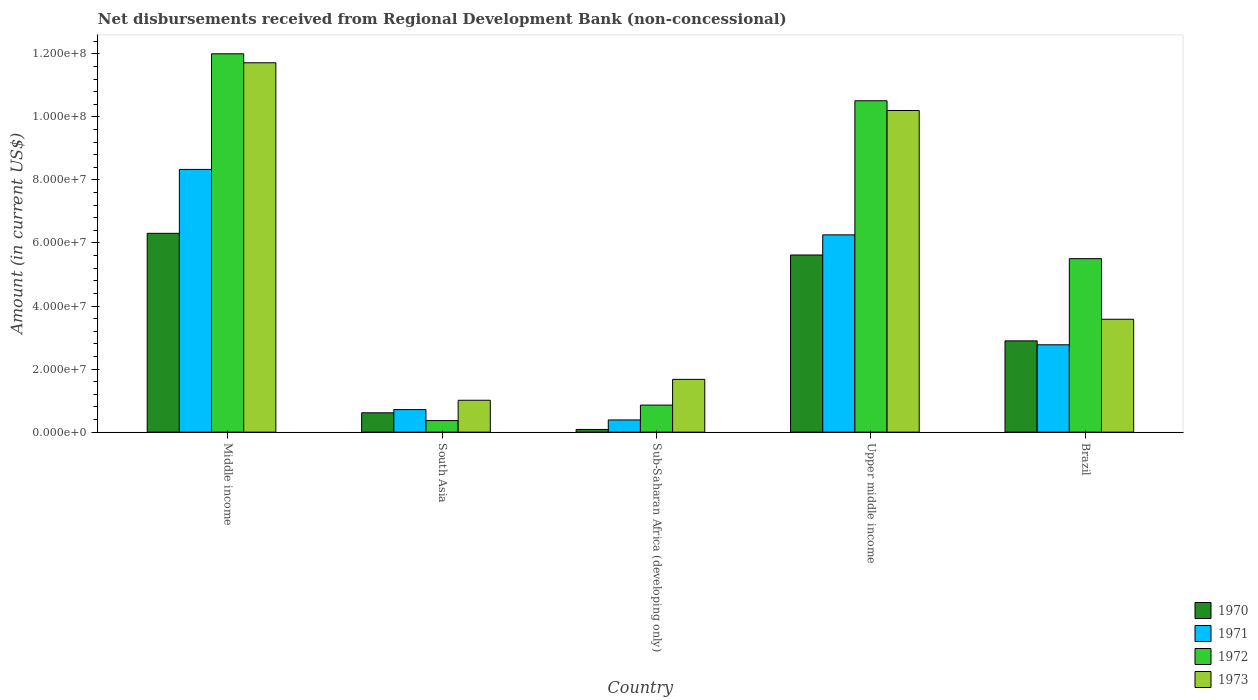How many different coloured bars are there?
Offer a very short reply. 4. How many bars are there on the 2nd tick from the left?
Your response must be concise. 4. How many bars are there on the 4th tick from the right?
Offer a very short reply. 4. What is the amount of disbursements received from Regional Development Bank in 1970 in South Asia?
Provide a short and direct response. 6.13e+06. Across all countries, what is the maximum amount of disbursements received from Regional Development Bank in 1973?
Ensure brevity in your answer.  1.17e+08. Across all countries, what is the minimum amount of disbursements received from Regional Development Bank in 1971?
Your response must be concise. 3.87e+06. In which country was the amount of disbursements received from Regional Development Bank in 1970 maximum?
Make the answer very short. Middle income. In which country was the amount of disbursements received from Regional Development Bank in 1971 minimum?
Offer a terse response. Sub-Saharan Africa (developing only). What is the total amount of disbursements received from Regional Development Bank in 1970 in the graph?
Provide a succinct answer. 1.55e+08. What is the difference between the amount of disbursements received from Regional Development Bank in 1970 in Brazil and that in South Asia?
Provide a short and direct response. 2.28e+07. What is the difference between the amount of disbursements received from Regional Development Bank in 1972 in Upper middle income and the amount of disbursements received from Regional Development Bank in 1971 in Sub-Saharan Africa (developing only)?
Your answer should be compact. 1.01e+08. What is the average amount of disbursements received from Regional Development Bank in 1971 per country?
Give a very brief answer. 3.69e+07. What is the difference between the amount of disbursements received from Regional Development Bank of/in 1972 and amount of disbursements received from Regional Development Bank of/in 1973 in Sub-Saharan Africa (developing only)?
Provide a succinct answer. -8.16e+06. In how many countries, is the amount of disbursements received from Regional Development Bank in 1971 greater than 8000000 US$?
Your response must be concise. 3. What is the ratio of the amount of disbursements received from Regional Development Bank in 1971 in Brazil to that in Upper middle income?
Provide a succinct answer. 0.44. Is the amount of disbursements received from Regional Development Bank in 1973 in Brazil less than that in Upper middle income?
Offer a very short reply. Yes. What is the difference between the highest and the second highest amount of disbursements received from Regional Development Bank in 1973?
Ensure brevity in your answer.  1.51e+07. What is the difference between the highest and the lowest amount of disbursements received from Regional Development Bank in 1970?
Your answer should be compact. 6.22e+07. What does the 2nd bar from the left in Upper middle income represents?
Your answer should be compact. 1971. What does the 2nd bar from the right in South Asia represents?
Your response must be concise. 1972. How many bars are there?
Make the answer very short. 20. Are all the bars in the graph horizontal?
Your response must be concise. No. How many countries are there in the graph?
Keep it short and to the point. 5. Are the values on the major ticks of Y-axis written in scientific E-notation?
Your response must be concise. Yes. Does the graph contain grids?
Your answer should be very brief. No. Where does the legend appear in the graph?
Offer a very short reply. Bottom right. What is the title of the graph?
Provide a succinct answer. Net disbursements received from Regional Development Bank (non-concessional). What is the label or title of the X-axis?
Offer a very short reply. Country. What is the label or title of the Y-axis?
Offer a terse response. Amount (in current US$). What is the Amount (in current US$) of 1970 in Middle income?
Ensure brevity in your answer.  6.31e+07. What is the Amount (in current US$) of 1971 in Middle income?
Provide a succinct answer. 8.33e+07. What is the Amount (in current US$) of 1972 in Middle income?
Offer a very short reply. 1.20e+08. What is the Amount (in current US$) in 1973 in Middle income?
Your answer should be compact. 1.17e+08. What is the Amount (in current US$) of 1970 in South Asia?
Keep it short and to the point. 6.13e+06. What is the Amount (in current US$) in 1971 in South Asia?
Provide a succinct answer. 7.16e+06. What is the Amount (in current US$) in 1972 in South Asia?
Make the answer very short. 3.67e+06. What is the Amount (in current US$) in 1973 in South Asia?
Ensure brevity in your answer.  1.01e+07. What is the Amount (in current US$) of 1970 in Sub-Saharan Africa (developing only)?
Your answer should be compact. 8.50e+05. What is the Amount (in current US$) in 1971 in Sub-Saharan Africa (developing only)?
Your answer should be compact. 3.87e+06. What is the Amount (in current US$) in 1972 in Sub-Saharan Africa (developing only)?
Your response must be concise. 8.58e+06. What is the Amount (in current US$) in 1973 in Sub-Saharan Africa (developing only)?
Make the answer very short. 1.67e+07. What is the Amount (in current US$) in 1970 in Upper middle income?
Provide a succinct answer. 5.62e+07. What is the Amount (in current US$) of 1971 in Upper middle income?
Give a very brief answer. 6.26e+07. What is the Amount (in current US$) of 1972 in Upper middle income?
Provide a succinct answer. 1.05e+08. What is the Amount (in current US$) of 1973 in Upper middle income?
Provide a short and direct response. 1.02e+08. What is the Amount (in current US$) of 1970 in Brazil?
Ensure brevity in your answer.  2.90e+07. What is the Amount (in current US$) of 1971 in Brazil?
Give a very brief answer. 2.77e+07. What is the Amount (in current US$) of 1972 in Brazil?
Make the answer very short. 5.50e+07. What is the Amount (in current US$) in 1973 in Brazil?
Provide a succinct answer. 3.58e+07. Across all countries, what is the maximum Amount (in current US$) of 1970?
Offer a very short reply. 6.31e+07. Across all countries, what is the maximum Amount (in current US$) in 1971?
Your answer should be compact. 8.33e+07. Across all countries, what is the maximum Amount (in current US$) of 1972?
Offer a very short reply. 1.20e+08. Across all countries, what is the maximum Amount (in current US$) of 1973?
Keep it short and to the point. 1.17e+08. Across all countries, what is the minimum Amount (in current US$) in 1970?
Make the answer very short. 8.50e+05. Across all countries, what is the minimum Amount (in current US$) in 1971?
Give a very brief answer. 3.87e+06. Across all countries, what is the minimum Amount (in current US$) of 1972?
Ensure brevity in your answer.  3.67e+06. Across all countries, what is the minimum Amount (in current US$) of 1973?
Make the answer very short. 1.01e+07. What is the total Amount (in current US$) of 1970 in the graph?
Offer a terse response. 1.55e+08. What is the total Amount (in current US$) of 1971 in the graph?
Ensure brevity in your answer.  1.85e+08. What is the total Amount (in current US$) of 1972 in the graph?
Offer a terse response. 2.92e+08. What is the total Amount (in current US$) in 1973 in the graph?
Your answer should be very brief. 2.82e+08. What is the difference between the Amount (in current US$) in 1970 in Middle income and that in South Asia?
Your answer should be compact. 5.69e+07. What is the difference between the Amount (in current US$) of 1971 in Middle income and that in South Asia?
Offer a very short reply. 7.62e+07. What is the difference between the Amount (in current US$) of 1972 in Middle income and that in South Asia?
Offer a terse response. 1.16e+08. What is the difference between the Amount (in current US$) of 1973 in Middle income and that in South Asia?
Your answer should be very brief. 1.07e+08. What is the difference between the Amount (in current US$) of 1970 in Middle income and that in Sub-Saharan Africa (developing only)?
Give a very brief answer. 6.22e+07. What is the difference between the Amount (in current US$) in 1971 in Middle income and that in Sub-Saharan Africa (developing only)?
Keep it short and to the point. 7.95e+07. What is the difference between the Amount (in current US$) of 1972 in Middle income and that in Sub-Saharan Africa (developing only)?
Provide a short and direct response. 1.11e+08. What is the difference between the Amount (in current US$) of 1973 in Middle income and that in Sub-Saharan Africa (developing only)?
Provide a succinct answer. 1.00e+08. What is the difference between the Amount (in current US$) in 1970 in Middle income and that in Upper middle income?
Offer a very short reply. 6.87e+06. What is the difference between the Amount (in current US$) of 1971 in Middle income and that in Upper middle income?
Keep it short and to the point. 2.08e+07. What is the difference between the Amount (in current US$) in 1972 in Middle income and that in Upper middle income?
Offer a terse response. 1.49e+07. What is the difference between the Amount (in current US$) of 1973 in Middle income and that in Upper middle income?
Your response must be concise. 1.51e+07. What is the difference between the Amount (in current US$) of 1970 in Middle income and that in Brazil?
Your answer should be very brief. 3.41e+07. What is the difference between the Amount (in current US$) in 1971 in Middle income and that in Brazil?
Ensure brevity in your answer.  5.56e+07. What is the difference between the Amount (in current US$) in 1972 in Middle income and that in Brazil?
Offer a terse response. 6.50e+07. What is the difference between the Amount (in current US$) of 1973 in Middle income and that in Brazil?
Keep it short and to the point. 8.13e+07. What is the difference between the Amount (in current US$) of 1970 in South Asia and that in Sub-Saharan Africa (developing only)?
Give a very brief answer. 5.28e+06. What is the difference between the Amount (in current US$) in 1971 in South Asia and that in Sub-Saharan Africa (developing only)?
Your answer should be compact. 3.29e+06. What is the difference between the Amount (in current US$) in 1972 in South Asia and that in Sub-Saharan Africa (developing only)?
Make the answer very short. -4.91e+06. What is the difference between the Amount (in current US$) of 1973 in South Asia and that in Sub-Saharan Africa (developing only)?
Make the answer very short. -6.63e+06. What is the difference between the Amount (in current US$) in 1970 in South Asia and that in Upper middle income?
Your answer should be compact. -5.01e+07. What is the difference between the Amount (in current US$) of 1971 in South Asia and that in Upper middle income?
Ensure brevity in your answer.  -5.54e+07. What is the difference between the Amount (in current US$) of 1972 in South Asia and that in Upper middle income?
Keep it short and to the point. -1.01e+08. What is the difference between the Amount (in current US$) of 1973 in South Asia and that in Upper middle income?
Offer a terse response. -9.19e+07. What is the difference between the Amount (in current US$) in 1970 in South Asia and that in Brazil?
Provide a short and direct response. -2.28e+07. What is the difference between the Amount (in current US$) in 1971 in South Asia and that in Brazil?
Ensure brevity in your answer.  -2.05e+07. What is the difference between the Amount (in current US$) of 1972 in South Asia and that in Brazil?
Ensure brevity in your answer.  -5.14e+07. What is the difference between the Amount (in current US$) in 1973 in South Asia and that in Brazil?
Keep it short and to the point. -2.57e+07. What is the difference between the Amount (in current US$) in 1970 in Sub-Saharan Africa (developing only) and that in Upper middle income?
Provide a succinct answer. -5.53e+07. What is the difference between the Amount (in current US$) in 1971 in Sub-Saharan Africa (developing only) and that in Upper middle income?
Give a very brief answer. -5.87e+07. What is the difference between the Amount (in current US$) in 1972 in Sub-Saharan Africa (developing only) and that in Upper middle income?
Your answer should be compact. -9.65e+07. What is the difference between the Amount (in current US$) in 1973 in Sub-Saharan Africa (developing only) and that in Upper middle income?
Offer a very short reply. -8.53e+07. What is the difference between the Amount (in current US$) in 1970 in Sub-Saharan Africa (developing only) and that in Brazil?
Provide a succinct answer. -2.81e+07. What is the difference between the Amount (in current US$) in 1971 in Sub-Saharan Africa (developing only) and that in Brazil?
Your answer should be very brief. -2.38e+07. What is the difference between the Amount (in current US$) in 1972 in Sub-Saharan Africa (developing only) and that in Brazil?
Make the answer very short. -4.64e+07. What is the difference between the Amount (in current US$) of 1973 in Sub-Saharan Africa (developing only) and that in Brazil?
Give a very brief answer. -1.91e+07. What is the difference between the Amount (in current US$) in 1970 in Upper middle income and that in Brazil?
Give a very brief answer. 2.72e+07. What is the difference between the Amount (in current US$) of 1971 in Upper middle income and that in Brazil?
Provide a short and direct response. 3.49e+07. What is the difference between the Amount (in current US$) of 1972 in Upper middle income and that in Brazil?
Keep it short and to the point. 5.01e+07. What is the difference between the Amount (in current US$) in 1973 in Upper middle income and that in Brazil?
Ensure brevity in your answer.  6.62e+07. What is the difference between the Amount (in current US$) in 1970 in Middle income and the Amount (in current US$) in 1971 in South Asia?
Provide a succinct answer. 5.59e+07. What is the difference between the Amount (in current US$) in 1970 in Middle income and the Amount (in current US$) in 1972 in South Asia?
Your answer should be very brief. 5.94e+07. What is the difference between the Amount (in current US$) of 1970 in Middle income and the Amount (in current US$) of 1973 in South Asia?
Make the answer very short. 5.29e+07. What is the difference between the Amount (in current US$) of 1971 in Middle income and the Amount (in current US$) of 1972 in South Asia?
Your answer should be compact. 7.97e+07. What is the difference between the Amount (in current US$) in 1971 in Middle income and the Amount (in current US$) in 1973 in South Asia?
Your answer should be very brief. 7.32e+07. What is the difference between the Amount (in current US$) in 1972 in Middle income and the Amount (in current US$) in 1973 in South Asia?
Provide a short and direct response. 1.10e+08. What is the difference between the Amount (in current US$) of 1970 in Middle income and the Amount (in current US$) of 1971 in Sub-Saharan Africa (developing only)?
Ensure brevity in your answer.  5.92e+07. What is the difference between the Amount (in current US$) of 1970 in Middle income and the Amount (in current US$) of 1972 in Sub-Saharan Africa (developing only)?
Keep it short and to the point. 5.45e+07. What is the difference between the Amount (in current US$) in 1970 in Middle income and the Amount (in current US$) in 1973 in Sub-Saharan Africa (developing only)?
Keep it short and to the point. 4.63e+07. What is the difference between the Amount (in current US$) of 1971 in Middle income and the Amount (in current US$) of 1972 in Sub-Saharan Africa (developing only)?
Your answer should be very brief. 7.47e+07. What is the difference between the Amount (in current US$) in 1971 in Middle income and the Amount (in current US$) in 1973 in Sub-Saharan Africa (developing only)?
Give a very brief answer. 6.66e+07. What is the difference between the Amount (in current US$) in 1972 in Middle income and the Amount (in current US$) in 1973 in Sub-Saharan Africa (developing only)?
Ensure brevity in your answer.  1.03e+08. What is the difference between the Amount (in current US$) in 1970 in Middle income and the Amount (in current US$) in 1971 in Upper middle income?
Keep it short and to the point. 4.82e+05. What is the difference between the Amount (in current US$) in 1970 in Middle income and the Amount (in current US$) in 1972 in Upper middle income?
Your answer should be compact. -4.20e+07. What is the difference between the Amount (in current US$) of 1970 in Middle income and the Amount (in current US$) of 1973 in Upper middle income?
Keep it short and to the point. -3.90e+07. What is the difference between the Amount (in current US$) of 1971 in Middle income and the Amount (in current US$) of 1972 in Upper middle income?
Provide a succinct answer. -2.18e+07. What is the difference between the Amount (in current US$) in 1971 in Middle income and the Amount (in current US$) in 1973 in Upper middle income?
Your answer should be very brief. -1.87e+07. What is the difference between the Amount (in current US$) in 1972 in Middle income and the Amount (in current US$) in 1973 in Upper middle income?
Your answer should be very brief. 1.80e+07. What is the difference between the Amount (in current US$) in 1970 in Middle income and the Amount (in current US$) in 1971 in Brazil?
Keep it short and to the point. 3.54e+07. What is the difference between the Amount (in current US$) in 1970 in Middle income and the Amount (in current US$) in 1972 in Brazil?
Ensure brevity in your answer.  8.04e+06. What is the difference between the Amount (in current US$) of 1970 in Middle income and the Amount (in current US$) of 1973 in Brazil?
Provide a succinct answer. 2.73e+07. What is the difference between the Amount (in current US$) in 1971 in Middle income and the Amount (in current US$) in 1972 in Brazil?
Keep it short and to the point. 2.83e+07. What is the difference between the Amount (in current US$) in 1971 in Middle income and the Amount (in current US$) in 1973 in Brazil?
Provide a succinct answer. 4.75e+07. What is the difference between the Amount (in current US$) in 1972 in Middle income and the Amount (in current US$) in 1973 in Brazil?
Make the answer very short. 8.42e+07. What is the difference between the Amount (in current US$) in 1970 in South Asia and the Amount (in current US$) in 1971 in Sub-Saharan Africa (developing only)?
Provide a short and direct response. 2.26e+06. What is the difference between the Amount (in current US$) of 1970 in South Asia and the Amount (in current US$) of 1972 in Sub-Saharan Africa (developing only)?
Offer a very short reply. -2.45e+06. What is the difference between the Amount (in current US$) of 1970 in South Asia and the Amount (in current US$) of 1973 in Sub-Saharan Africa (developing only)?
Make the answer very short. -1.06e+07. What is the difference between the Amount (in current US$) of 1971 in South Asia and the Amount (in current US$) of 1972 in Sub-Saharan Africa (developing only)?
Offer a terse response. -1.42e+06. What is the difference between the Amount (in current US$) of 1971 in South Asia and the Amount (in current US$) of 1973 in Sub-Saharan Africa (developing only)?
Provide a succinct answer. -9.58e+06. What is the difference between the Amount (in current US$) in 1972 in South Asia and the Amount (in current US$) in 1973 in Sub-Saharan Africa (developing only)?
Make the answer very short. -1.31e+07. What is the difference between the Amount (in current US$) in 1970 in South Asia and the Amount (in current US$) in 1971 in Upper middle income?
Make the answer very short. -5.64e+07. What is the difference between the Amount (in current US$) of 1970 in South Asia and the Amount (in current US$) of 1972 in Upper middle income?
Ensure brevity in your answer.  -9.90e+07. What is the difference between the Amount (in current US$) of 1970 in South Asia and the Amount (in current US$) of 1973 in Upper middle income?
Provide a succinct answer. -9.59e+07. What is the difference between the Amount (in current US$) in 1971 in South Asia and the Amount (in current US$) in 1972 in Upper middle income?
Your answer should be compact. -9.79e+07. What is the difference between the Amount (in current US$) in 1971 in South Asia and the Amount (in current US$) in 1973 in Upper middle income?
Ensure brevity in your answer.  -9.49e+07. What is the difference between the Amount (in current US$) of 1972 in South Asia and the Amount (in current US$) of 1973 in Upper middle income?
Offer a very short reply. -9.83e+07. What is the difference between the Amount (in current US$) of 1970 in South Asia and the Amount (in current US$) of 1971 in Brazil?
Ensure brevity in your answer.  -2.16e+07. What is the difference between the Amount (in current US$) of 1970 in South Asia and the Amount (in current US$) of 1972 in Brazil?
Provide a short and direct response. -4.89e+07. What is the difference between the Amount (in current US$) in 1970 in South Asia and the Amount (in current US$) in 1973 in Brazil?
Your response must be concise. -2.97e+07. What is the difference between the Amount (in current US$) of 1971 in South Asia and the Amount (in current US$) of 1972 in Brazil?
Your answer should be compact. -4.79e+07. What is the difference between the Amount (in current US$) of 1971 in South Asia and the Amount (in current US$) of 1973 in Brazil?
Give a very brief answer. -2.86e+07. What is the difference between the Amount (in current US$) of 1972 in South Asia and the Amount (in current US$) of 1973 in Brazil?
Your response must be concise. -3.21e+07. What is the difference between the Amount (in current US$) in 1970 in Sub-Saharan Africa (developing only) and the Amount (in current US$) in 1971 in Upper middle income?
Your answer should be very brief. -6.17e+07. What is the difference between the Amount (in current US$) in 1970 in Sub-Saharan Africa (developing only) and the Amount (in current US$) in 1972 in Upper middle income?
Your response must be concise. -1.04e+08. What is the difference between the Amount (in current US$) of 1970 in Sub-Saharan Africa (developing only) and the Amount (in current US$) of 1973 in Upper middle income?
Your answer should be very brief. -1.01e+08. What is the difference between the Amount (in current US$) in 1971 in Sub-Saharan Africa (developing only) and the Amount (in current US$) in 1972 in Upper middle income?
Ensure brevity in your answer.  -1.01e+08. What is the difference between the Amount (in current US$) in 1971 in Sub-Saharan Africa (developing only) and the Amount (in current US$) in 1973 in Upper middle income?
Your answer should be compact. -9.81e+07. What is the difference between the Amount (in current US$) in 1972 in Sub-Saharan Africa (developing only) and the Amount (in current US$) in 1973 in Upper middle income?
Your response must be concise. -9.34e+07. What is the difference between the Amount (in current US$) of 1970 in Sub-Saharan Africa (developing only) and the Amount (in current US$) of 1971 in Brazil?
Ensure brevity in your answer.  -2.69e+07. What is the difference between the Amount (in current US$) of 1970 in Sub-Saharan Africa (developing only) and the Amount (in current US$) of 1972 in Brazil?
Provide a short and direct response. -5.42e+07. What is the difference between the Amount (in current US$) of 1970 in Sub-Saharan Africa (developing only) and the Amount (in current US$) of 1973 in Brazil?
Keep it short and to the point. -3.50e+07. What is the difference between the Amount (in current US$) of 1971 in Sub-Saharan Africa (developing only) and the Amount (in current US$) of 1972 in Brazil?
Offer a terse response. -5.12e+07. What is the difference between the Amount (in current US$) of 1971 in Sub-Saharan Africa (developing only) and the Amount (in current US$) of 1973 in Brazil?
Ensure brevity in your answer.  -3.19e+07. What is the difference between the Amount (in current US$) of 1972 in Sub-Saharan Africa (developing only) and the Amount (in current US$) of 1973 in Brazil?
Your answer should be very brief. -2.72e+07. What is the difference between the Amount (in current US$) in 1970 in Upper middle income and the Amount (in current US$) in 1971 in Brazil?
Keep it short and to the point. 2.85e+07. What is the difference between the Amount (in current US$) of 1970 in Upper middle income and the Amount (in current US$) of 1972 in Brazil?
Your answer should be compact. 1.16e+06. What is the difference between the Amount (in current US$) of 1970 in Upper middle income and the Amount (in current US$) of 1973 in Brazil?
Provide a short and direct response. 2.04e+07. What is the difference between the Amount (in current US$) of 1971 in Upper middle income and the Amount (in current US$) of 1972 in Brazil?
Keep it short and to the point. 7.55e+06. What is the difference between the Amount (in current US$) in 1971 in Upper middle income and the Amount (in current US$) in 1973 in Brazil?
Your response must be concise. 2.68e+07. What is the difference between the Amount (in current US$) in 1972 in Upper middle income and the Amount (in current US$) in 1973 in Brazil?
Your answer should be compact. 6.93e+07. What is the average Amount (in current US$) of 1970 per country?
Your answer should be compact. 3.10e+07. What is the average Amount (in current US$) of 1971 per country?
Your answer should be very brief. 3.69e+07. What is the average Amount (in current US$) of 1972 per country?
Provide a short and direct response. 5.85e+07. What is the average Amount (in current US$) of 1973 per country?
Offer a terse response. 5.64e+07. What is the difference between the Amount (in current US$) in 1970 and Amount (in current US$) in 1971 in Middle income?
Make the answer very short. -2.03e+07. What is the difference between the Amount (in current US$) of 1970 and Amount (in current US$) of 1972 in Middle income?
Your response must be concise. -5.69e+07. What is the difference between the Amount (in current US$) of 1970 and Amount (in current US$) of 1973 in Middle income?
Offer a very short reply. -5.41e+07. What is the difference between the Amount (in current US$) of 1971 and Amount (in current US$) of 1972 in Middle income?
Your answer should be compact. -3.67e+07. What is the difference between the Amount (in current US$) of 1971 and Amount (in current US$) of 1973 in Middle income?
Your response must be concise. -3.38e+07. What is the difference between the Amount (in current US$) in 1972 and Amount (in current US$) in 1973 in Middle income?
Your answer should be compact. 2.85e+06. What is the difference between the Amount (in current US$) of 1970 and Amount (in current US$) of 1971 in South Asia?
Your answer should be very brief. -1.02e+06. What is the difference between the Amount (in current US$) of 1970 and Amount (in current US$) of 1972 in South Asia?
Ensure brevity in your answer.  2.46e+06. What is the difference between the Amount (in current US$) in 1970 and Amount (in current US$) in 1973 in South Asia?
Your answer should be very brief. -3.98e+06. What is the difference between the Amount (in current US$) of 1971 and Amount (in current US$) of 1972 in South Asia?
Ensure brevity in your answer.  3.49e+06. What is the difference between the Amount (in current US$) in 1971 and Amount (in current US$) in 1973 in South Asia?
Make the answer very short. -2.95e+06. What is the difference between the Amount (in current US$) in 1972 and Amount (in current US$) in 1973 in South Asia?
Your answer should be compact. -6.44e+06. What is the difference between the Amount (in current US$) in 1970 and Amount (in current US$) in 1971 in Sub-Saharan Africa (developing only)?
Your answer should be compact. -3.02e+06. What is the difference between the Amount (in current US$) of 1970 and Amount (in current US$) of 1972 in Sub-Saharan Africa (developing only)?
Your response must be concise. -7.73e+06. What is the difference between the Amount (in current US$) in 1970 and Amount (in current US$) in 1973 in Sub-Saharan Africa (developing only)?
Your response must be concise. -1.59e+07. What is the difference between the Amount (in current US$) in 1971 and Amount (in current US$) in 1972 in Sub-Saharan Africa (developing only)?
Provide a short and direct response. -4.71e+06. What is the difference between the Amount (in current US$) of 1971 and Amount (in current US$) of 1973 in Sub-Saharan Africa (developing only)?
Your answer should be compact. -1.29e+07. What is the difference between the Amount (in current US$) in 1972 and Amount (in current US$) in 1973 in Sub-Saharan Africa (developing only)?
Ensure brevity in your answer.  -8.16e+06. What is the difference between the Amount (in current US$) of 1970 and Amount (in current US$) of 1971 in Upper middle income?
Make the answer very short. -6.39e+06. What is the difference between the Amount (in current US$) in 1970 and Amount (in current US$) in 1972 in Upper middle income?
Your answer should be very brief. -4.89e+07. What is the difference between the Amount (in current US$) in 1970 and Amount (in current US$) in 1973 in Upper middle income?
Offer a terse response. -4.58e+07. What is the difference between the Amount (in current US$) of 1971 and Amount (in current US$) of 1972 in Upper middle income?
Make the answer very short. -4.25e+07. What is the difference between the Amount (in current US$) of 1971 and Amount (in current US$) of 1973 in Upper middle income?
Your response must be concise. -3.94e+07. What is the difference between the Amount (in current US$) of 1972 and Amount (in current US$) of 1973 in Upper middle income?
Offer a terse response. 3.08e+06. What is the difference between the Amount (in current US$) of 1970 and Amount (in current US$) of 1971 in Brazil?
Your response must be concise. 1.25e+06. What is the difference between the Amount (in current US$) in 1970 and Amount (in current US$) in 1972 in Brazil?
Offer a very short reply. -2.61e+07. What is the difference between the Amount (in current US$) in 1970 and Amount (in current US$) in 1973 in Brazil?
Give a very brief answer. -6.85e+06. What is the difference between the Amount (in current US$) in 1971 and Amount (in current US$) in 1972 in Brazil?
Offer a terse response. -2.73e+07. What is the difference between the Amount (in current US$) in 1971 and Amount (in current US$) in 1973 in Brazil?
Your answer should be compact. -8.10e+06. What is the difference between the Amount (in current US$) of 1972 and Amount (in current US$) of 1973 in Brazil?
Ensure brevity in your answer.  1.92e+07. What is the ratio of the Amount (in current US$) in 1970 in Middle income to that in South Asia?
Keep it short and to the point. 10.28. What is the ratio of the Amount (in current US$) of 1971 in Middle income to that in South Asia?
Give a very brief answer. 11.64. What is the ratio of the Amount (in current US$) in 1972 in Middle income to that in South Asia?
Make the answer very short. 32.71. What is the ratio of the Amount (in current US$) in 1973 in Middle income to that in South Asia?
Offer a very short reply. 11.58. What is the ratio of the Amount (in current US$) of 1970 in Middle income to that in Sub-Saharan Africa (developing only)?
Provide a succinct answer. 74.18. What is the ratio of the Amount (in current US$) in 1971 in Middle income to that in Sub-Saharan Africa (developing only)?
Your answer should be compact. 21.54. What is the ratio of the Amount (in current US$) in 1972 in Middle income to that in Sub-Saharan Africa (developing only)?
Provide a succinct answer. 13.98. What is the ratio of the Amount (in current US$) of 1973 in Middle income to that in Sub-Saharan Africa (developing only)?
Your answer should be very brief. 7. What is the ratio of the Amount (in current US$) in 1970 in Middle income to that in Upper middle income?
Your response must be concise. 1.12. What is the ratio of the Amount (in current US$) in 1971 in Middle income to that in Upper middle income?
Ensure brevity in your answer.  1.33. What is the ratio of the Amount (in current US$) in 1972 in Middle income to that in Upper middle income?
Provide a short and direct response. 1.14. What is the ratio of the Amount (in current US$) of 1973 in Middle income to that in Upper middle income?
Give a very brief answer. 1.15. What is the ratio of the Amount (in current US$) in 1970 in Middle income to that in Brazil?
Provide a short and direct response. 2.18. What is the ratio of the Amount (in current US$) of 1971 in Middle income to that in Brazil?
Ensure brevity in your answer.  3.01. What is the ratio of the Amount (in current US$) of 1972 in Middle income to that in Brazil?
Keep it short and to the point. 2.18. What is the ratio of the Amount (in current US$) in 1973 in Middle income to that in Brazil?
Offer a terse response. 3.27. What is the ratio of the Amount (in current US$) of 1970 in South Asia to that in Sub-Saharan Africa (developing only)?
Offer a terse response. 7.22. What is the ratio of the Amount (in current US$) of 1971 in South Asia to that in Sub-Saharan Africa (developing only)?
Your answer should be very brief. 1.85. What is the ratio of the Amount (in current US$) in 1972 in South Asia to that in Sub-Saharan Africa (developing only)?
Offer a terse response. 0.43. What is the ratio of the Amount (in current US$) in 1973 in South Asia to that in Sub-Saharan Africa (developing only)?
Keep it short and to the point. 0.6. What is the ratio of the Amount (in current US$) of 1970 in South Asia to that in Upper middle income?
Offer a very short reply. 0.11. What is the ratio of the Amount (in current US$) of 1971 in South Asia to that in Upper middle income?
Offer a very short reply. 0.11. What is the ratio of the Amount (in current US$) of 1972 in South Asia to that in Upper middle income?
Provide a succinct answer. 0.03. What is the ratio of the Amount (in current US$) of 1973 in South Asia to that in Upper middle income?
Provide a short and direct response. 0.1. What is the ratio of the Amount (in current US$) in 1970 in South Asia to that in Brazil?
Ensure brevity in your answer.  0.21. What is the ratio of the Amount (in current US$) in 1971 in South Asia to that in Brazil?
Keep it short and to the point. 0.26. What is the ratio of the Amount (in current US$) of 1972 in South Asia to that in Brazil?
Your answer should be compact. 0.07. What is the ratio of the Amount (in current US$) of 1973 in South Asia to that in Brazil?
Ensure brevity in your answer.  0.28. What is the ratio of the Amount (in current US$) of 1970 in Sub-Saharan Africa (developing only) to that in Upper middle income?
Provide a succinct answer. 0.02. What is the ratio of the Amount (in current US$) in 1971 in Sub-Saharan Africa (developing only) to that in Upper middle income?
Offer a very short reply. 0.06. What is the ratio of the Amount (in current US$) of 1972 in Sub-Saharan Africa (developing only) to that in Upper middle income?
Offer a terse response. 0.08. What is the ratio of the Amount (in current US$) in 1973 in Sub-Saharan Africa (developing only) to that in Upper middle income?
Your answer should be compact. 0.16. What is the ratio of the Amount (in current US$) of 1970 in Sub-Saharan Africa (developing only) to that in Brazil?
Your answer should be compact. 0.03. What is the ratio of the Amount (in current US$) in 1971 in Sub-Saharan Africa (developing only) to that in Brazil?
Provide a short and direct response. 0.14. What is the ratio of the Amount (in current US$) of 1972 in Sub-Saharan Africa (developing only) to that in Brazil?
Offer a terse response. 0.16. What is the ratio of the Amount (in current US$) in 1973 in Sub-Saharan Africa (developing only) to that in Brazil?
Provide a succinct answer. 0.47. What is the ratio of the Amount (in current US$) of 1970 in Upper middle income to that in Brazil?
Provide a short and direct response. 1.94. What is the ratio of the Amount (in current US$) of 1971 in Upper middle income to that in Brazil?
Your response must be concise. 2.26. What is the ratio of the Amount (in current US$) of 1972 in Upper middle income to that in Brazil?
Give a very brief answer. 1.91. What is the ratio of the Amount (in current US$) in 1973 in Upper middle income to that in Brazil?
Offer a very short reply. 2.85. What is the difference between the highest and the second highest Amount (in current US$) of 1970?
Your answer should be very brief. 6.87e+06. What is the difference between the highest and the second highest Amount (in current US$) in 1971?
Provide a short and direct response. 2.08e+07. What is the difference between the highest and the second highest Amount (in current US$) of 1972?
Provide a short and direct response. 1.49e+07. What is the difference between the highest and the second highest Amount (in current US$) in 1973?
Keep it short and to the point. 1.51e+07. What is the difference between the highest and the lowest Amount (in current US$) in 1970?
Your response must be concise. 6.22e+07. What is the difference between the highest and the lowest Amount (in current US$) in 1971?
Ensure brevity in your answer.  7.95e+07. What is the difference between the highest and the lowest Amount (in current US$) of 1972?
Provide a succinct answer. 1.16e+08. What is the difference between the highest and the lowest Amount (in current US$) of 1973?
Ensure brevity in your answer.  1.07e+08. 